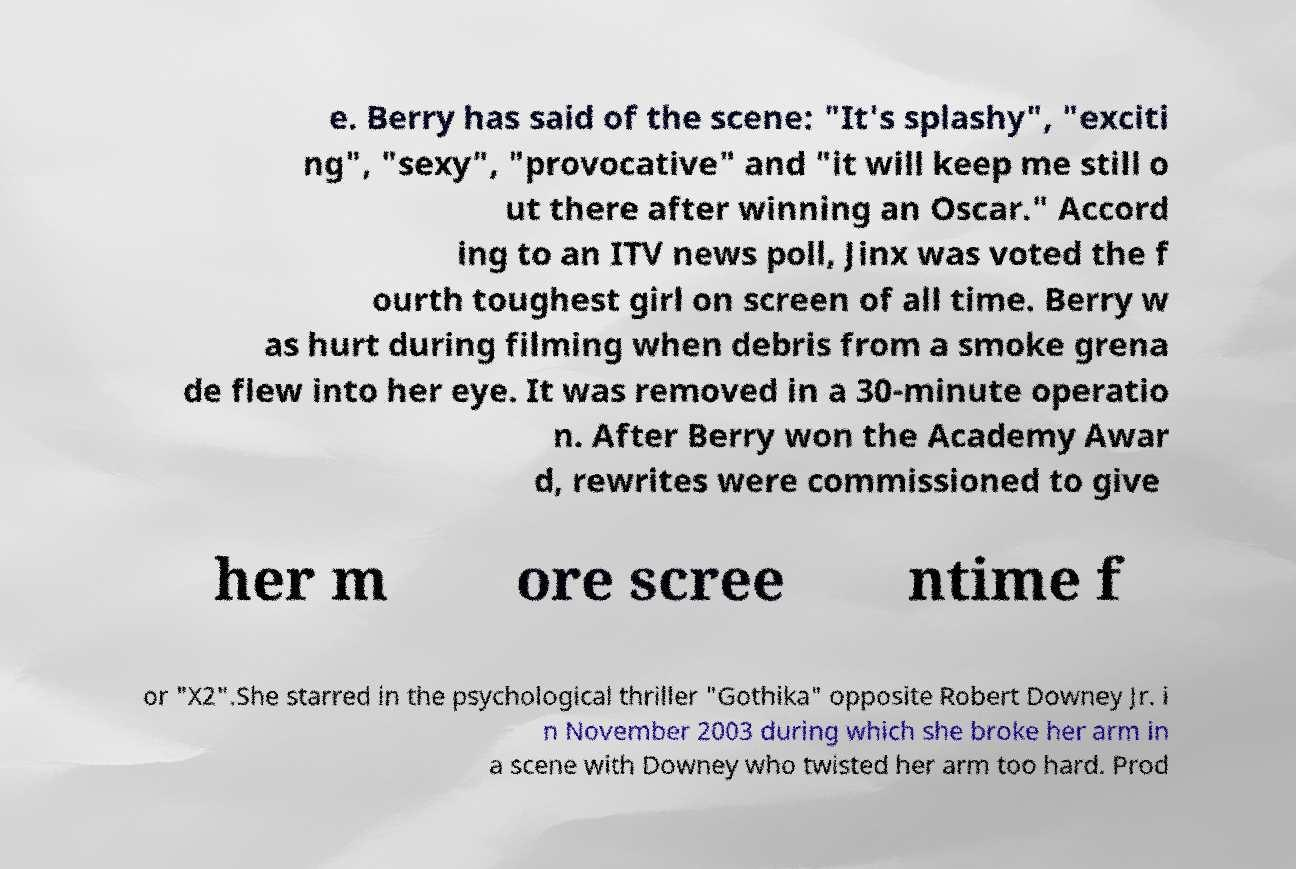Can you read and provide the text displayed in the image?This photo seems to have some interesting text. Can you extract and type it out for me? e. Berry has said of the scene: "It's splashy", "exciti ng", "sexy", "provocative" and "it will keep me still o ut there after winning an Oscar." Accord ing to an ITV news poll, Jinx was voted the f ourth toughest girl on screen of all time. Berry w as hurt during filming when debris from a smoke grena de flew into her eye. It was removed in a 30-minute operatio n. After Berry won the Academy Awar d, rewrites were commissioned to give her m ore scree ntime f or "X2".She starred in the psychological thriller "Gothika" opposite Robert Downey Jr. i n November 2003 during which she broke her arm in a scene with Downey who twisted her arm too hard. Prod 